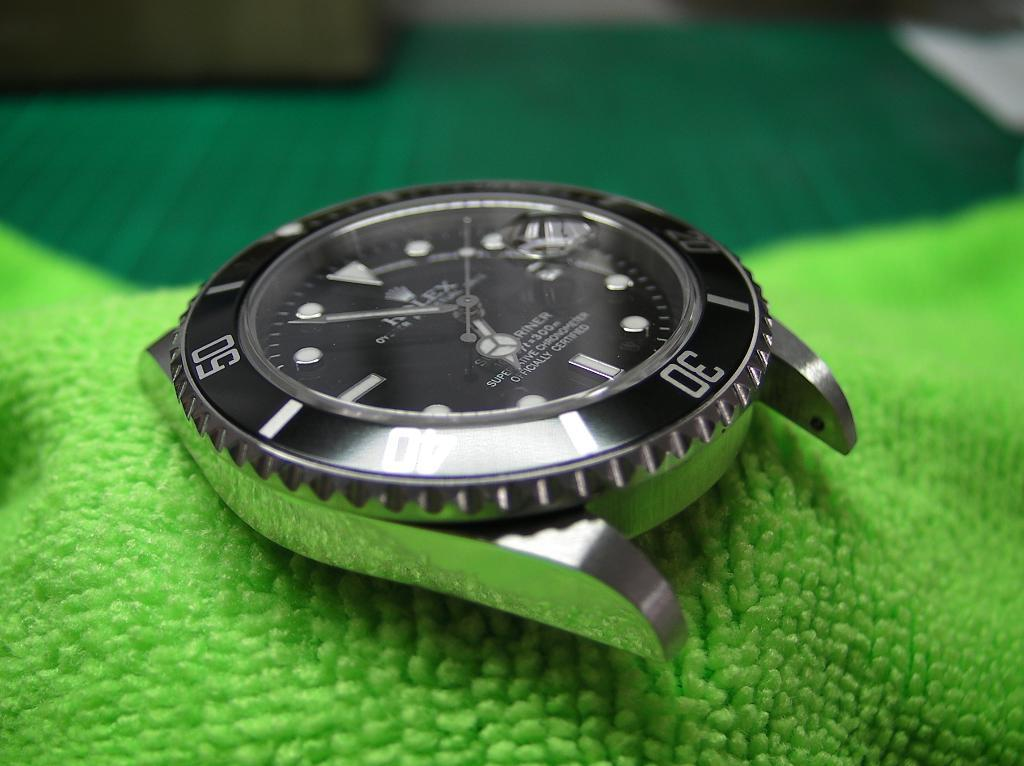<image>
Share a concise interpretation of the image provided. A silver Rolex watch face sits on a green cloth. 